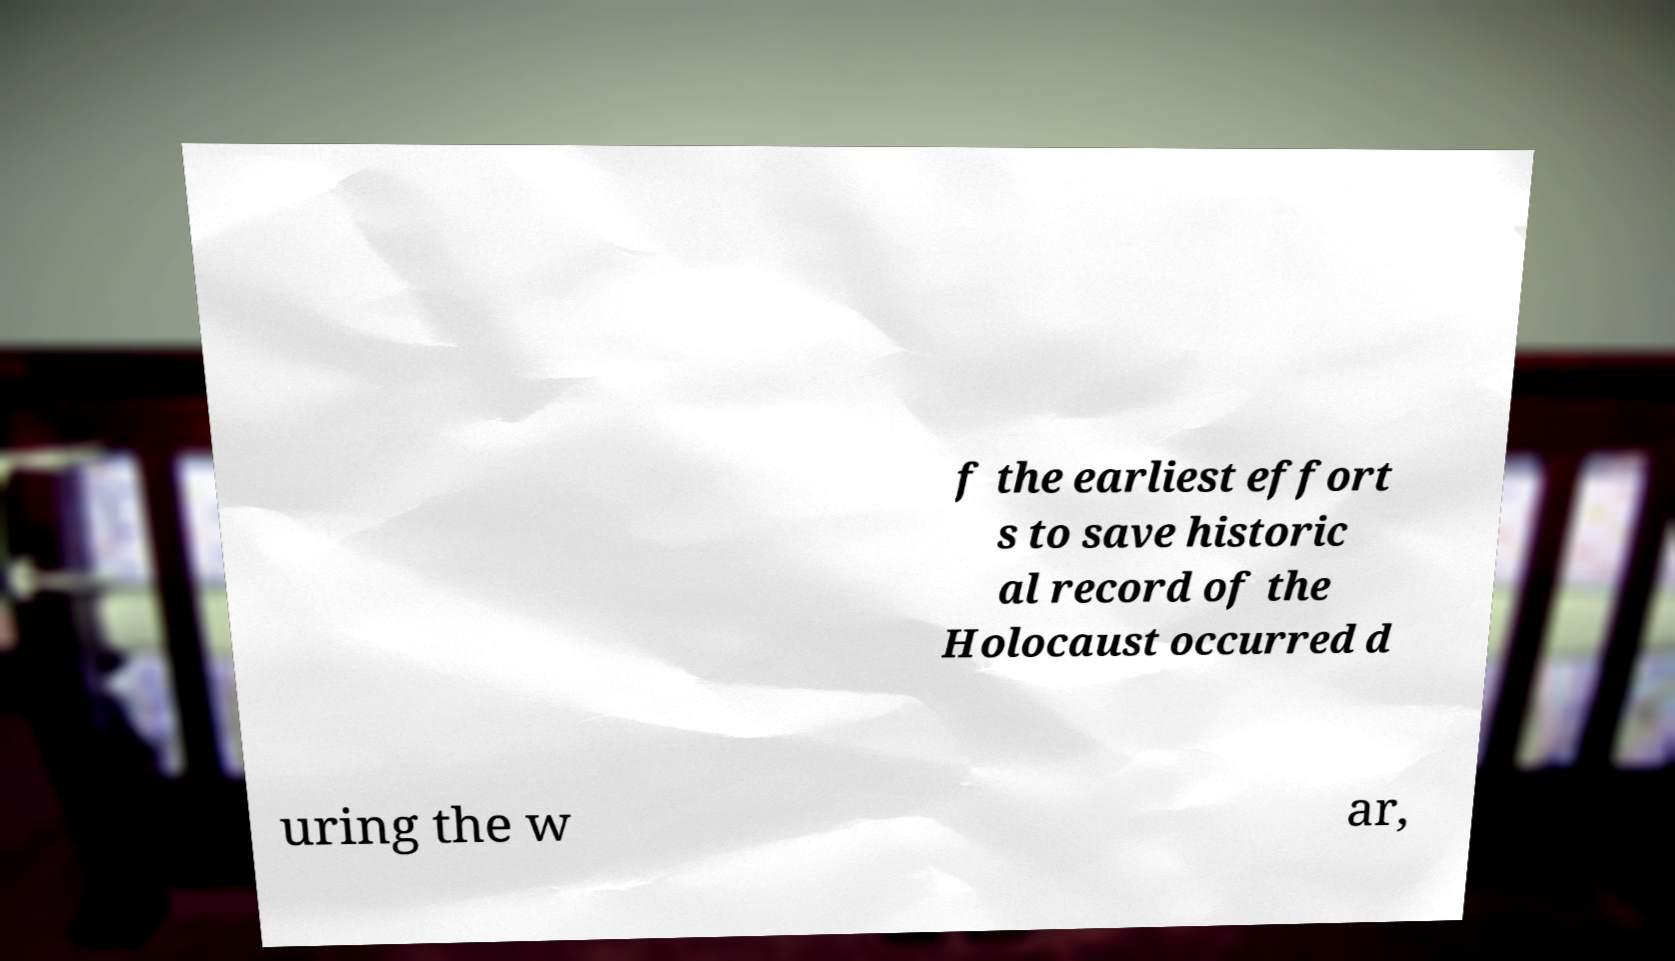Please identify and transcribe the text found in this image. f the earliest effort s to save historic al record of the Holocaust occurred d uring the w ar, 